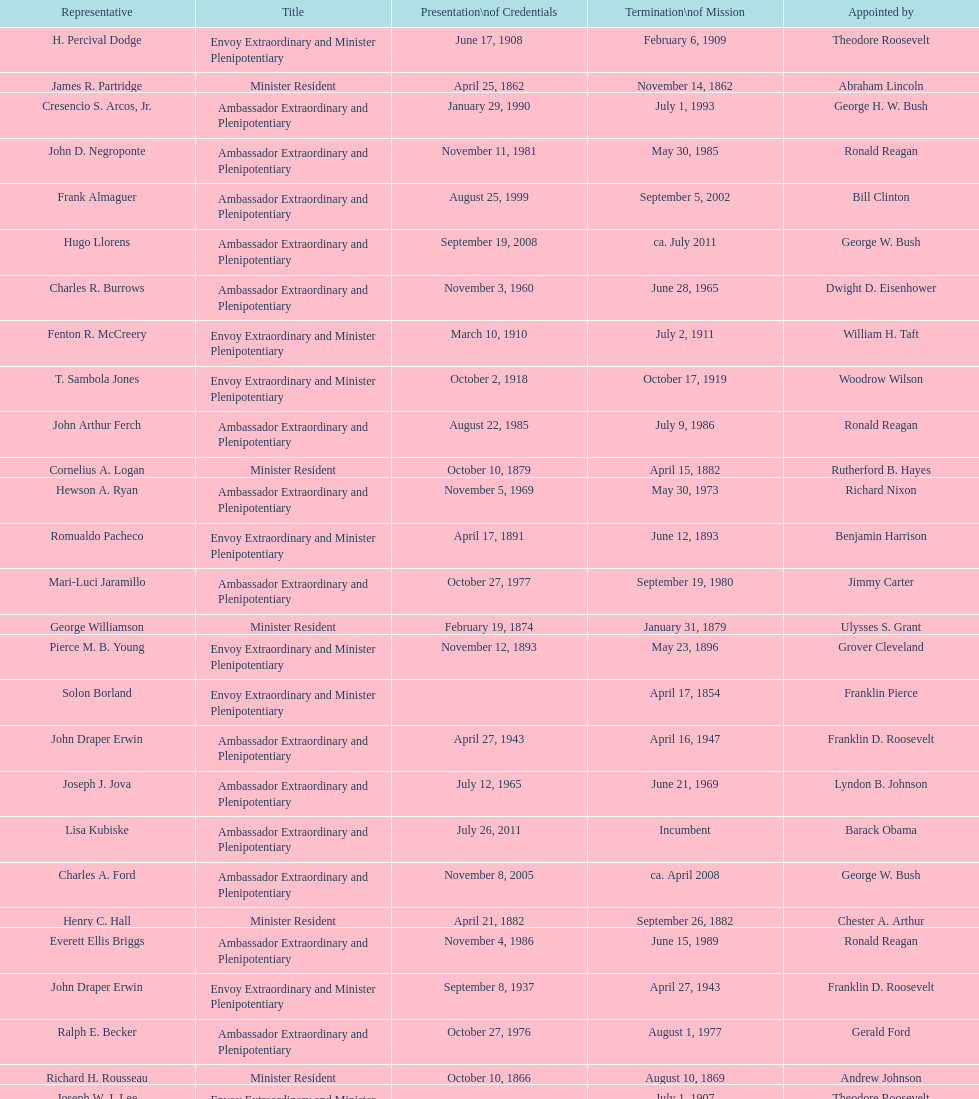Who is the only ambassadors to honduras appointed by barack obama? Lisa Kubiske. 